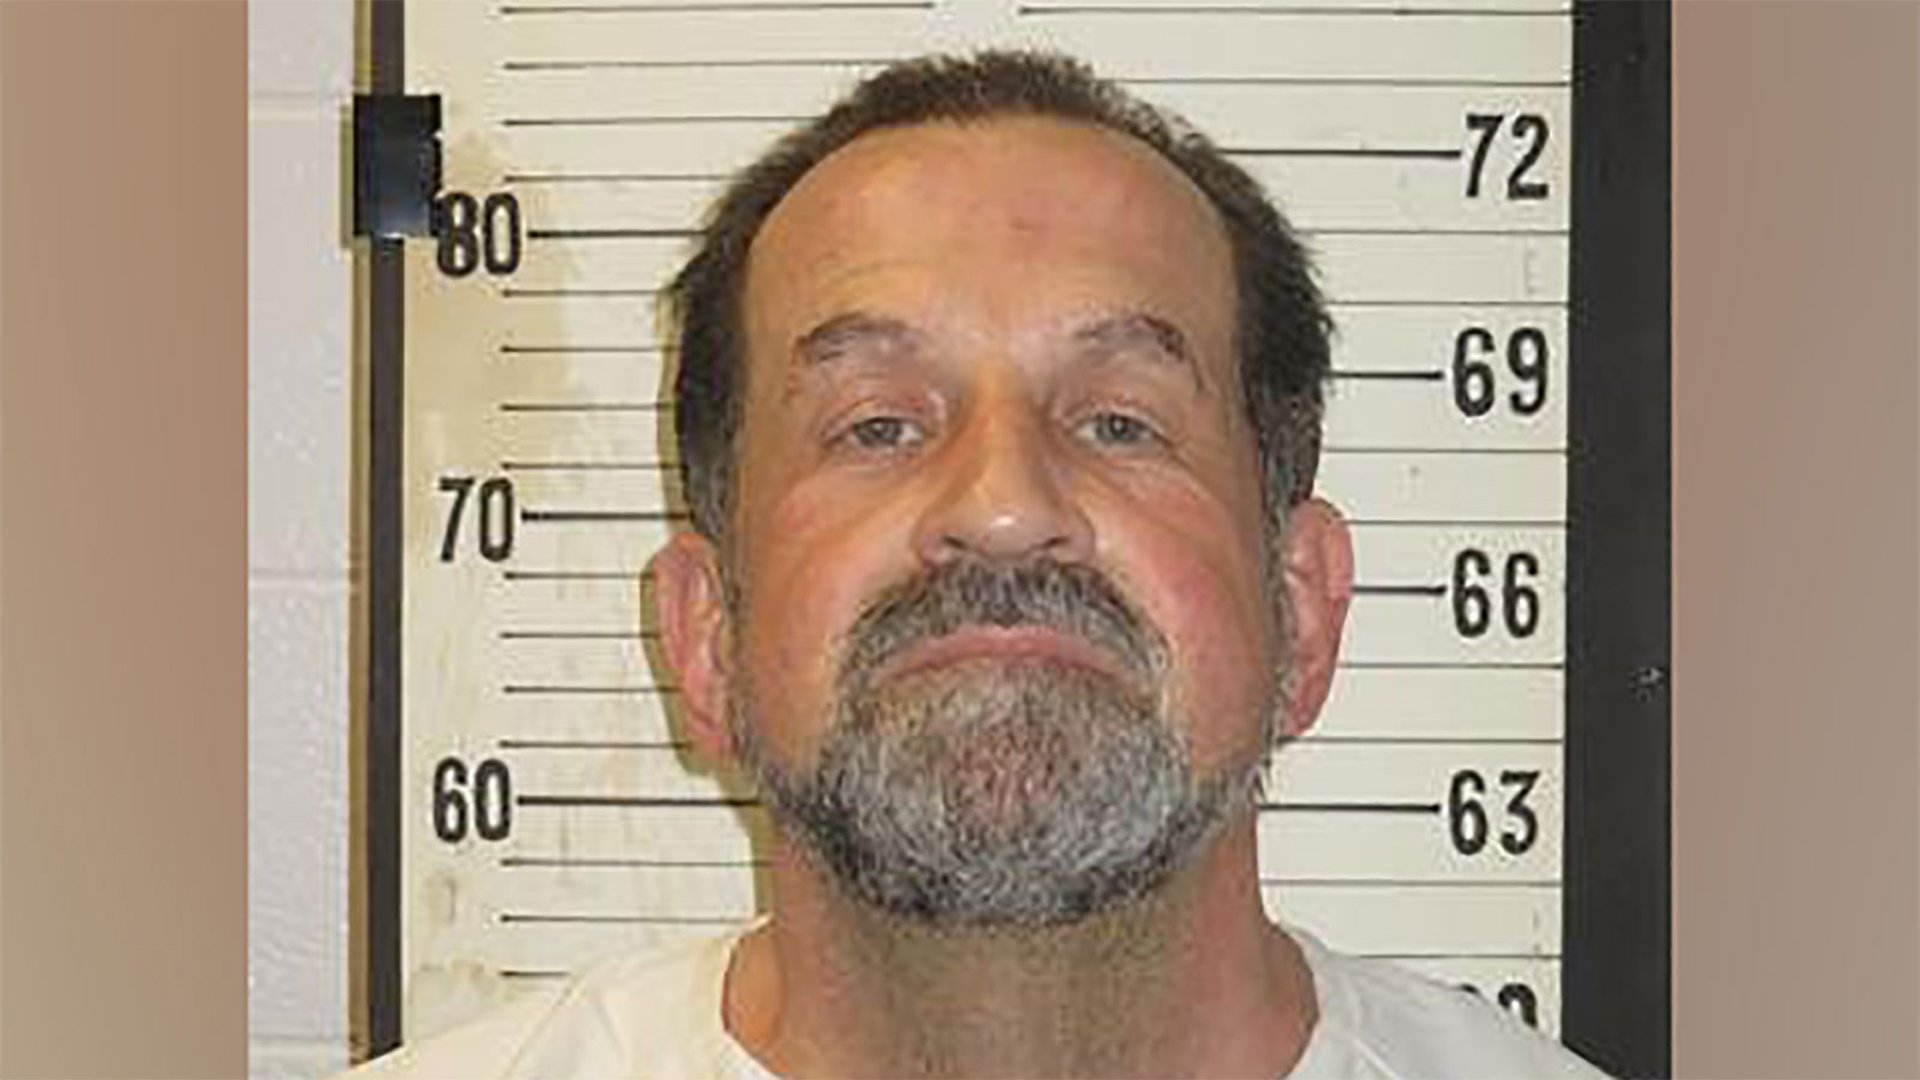Given the background, what kind of environment does this picture seem to be taken in? The visible height chart in the background suggests that this image was likely taken in a formal environment, such as a police station or correctional facility. The height chart is a common feature used for documentation in official processes, particularly in law enforcement settings. 